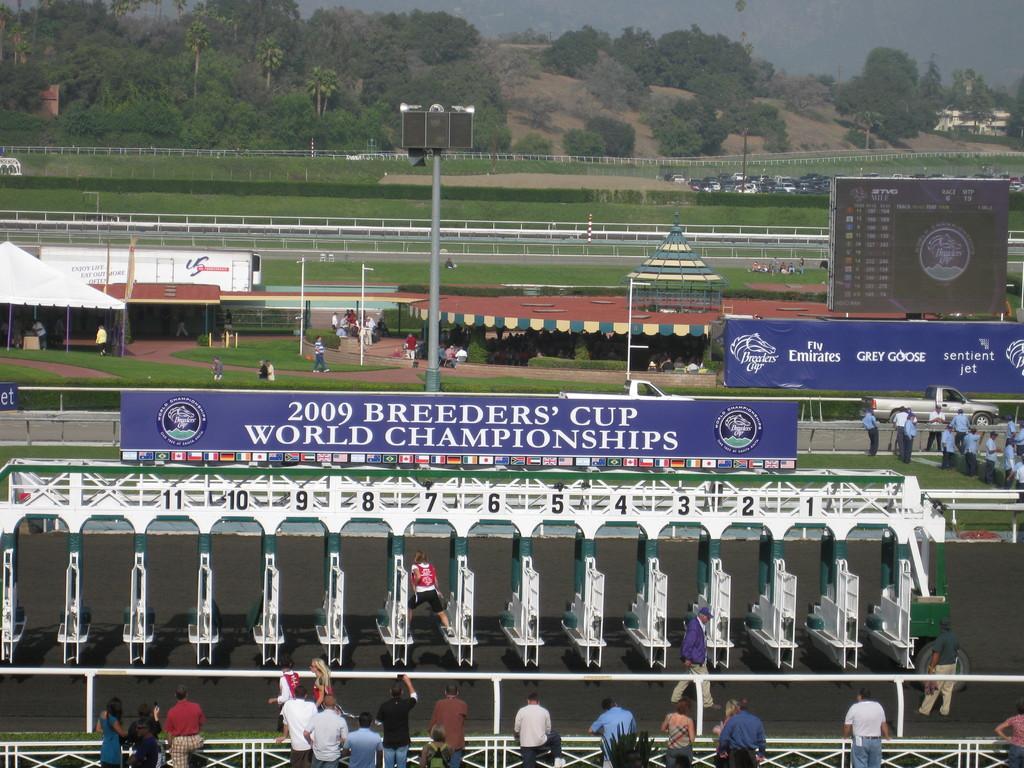Describe this image in one or two sentences. In this image I can see group of people standing and I can also see few boards attached to the poles and the boards are in blue color and I can also see few light poles, the railing. Background I can see the screen, trees in green color and I can also see few vehicles. 